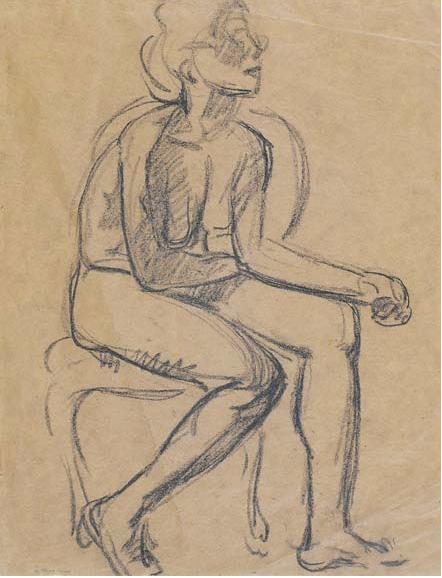Tell a fantastical story based on this image. In a realm where art comes to life, this figure is a guardian of the Gallery of Whispering Echoes. Each sketch and artwork in this gallery harbors ancient wisdom and secrets of the multiverse. The seated figure, known as Elarian the Meditative, is tasked with listening to the whispers of the paintings and sculptures, deciphering their cryptic messages to maintain the balance between worlds. One day, as Elarian gazes into the distance, a particularly vivid sketch begins to murmur of an encroaching darkness from the Forgotten Realm. With the fate of both their world and the Forgotten Realm hanging in the balance, Elarian must embark on a journey through the living gallery, seeking the wisdom of its myriad artworks to uncover a forgotten spell that can halt the impending chaos. Along the way, they encounter animated sculptures that guide them, sentient paintings that challenge their resolve, and ethereal corridors where time flows differently. This is a tale of courage, discovery, and the profound secrets hidden within the strokes of ancient artists. What might be the next challenge Elarian faces in this fantastical story? As Elarian traverses deeper into the Gallery of Whispering Echoes, they encounter the Hall of Reflective Shadows, a mysterious section where every artwork is a mirror that distorts reality. In this hall, Elarian's own reflections come to life, manifesting as shadowy doppelgängers that embody their deepest fears and insecurities. To move forward, Elarian must confront and overcome these inner demons, which challenge their wisdom, courage, and sense of self. Only by accepting their flaws and embracing their true nature can Elarian find the hidden passage to the Chamber of the Ancients, where the final piece of the forgotten spell resides. The challenge is as much a test of character as it is of capability, blending the line between psychological and physical trials in their quest. 